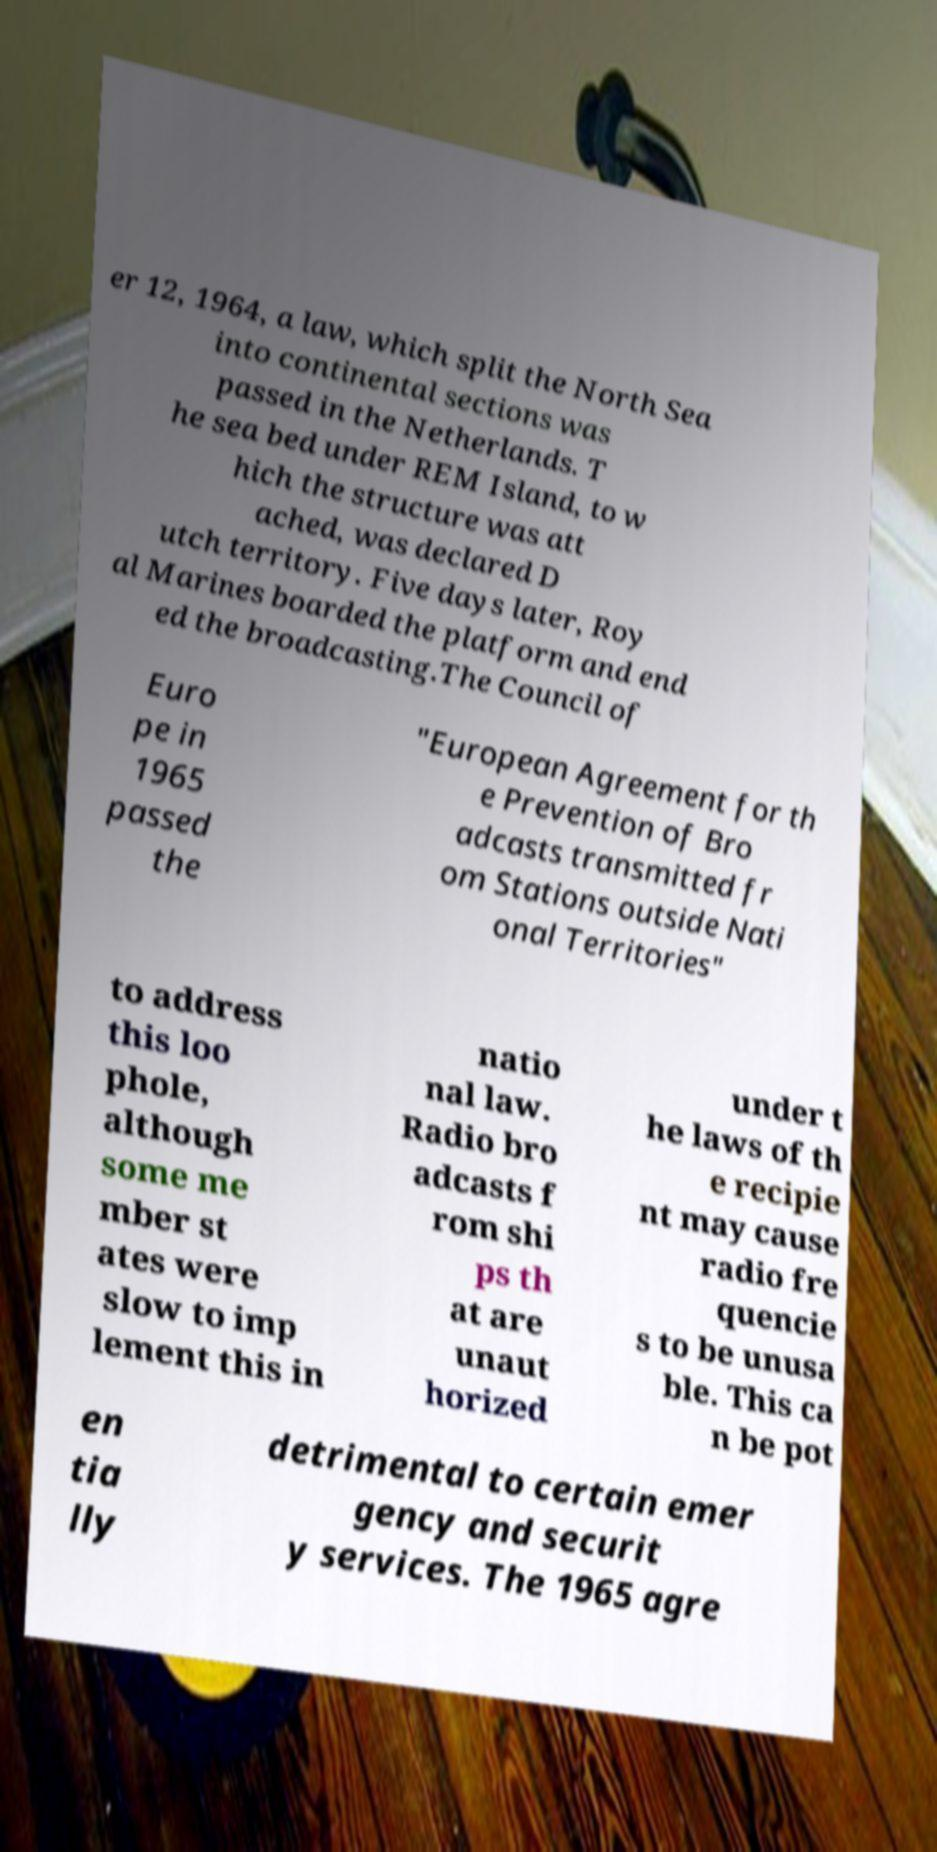Can you read and provide the text displayed in the image?This photo seems to have some interesting text. Can you extract and type it out for me? er 12, 1964, a law, which split the North Sea into continental sections was passed in the Netherlands. T he sea bed under REM Island, to w hich the structure was att ached, was declared D utch territory. Five days later, Roy al Marines boarded the platform and end ed the broadcasting.The Council of Euro pe in 1965 passed the "European Agreement for th e Prevention of Bro adcasts transmitted fr om Stations outside Nati onal Territories" to address this loo phole, although some me mber st ates were slow to imp lement this in natio nal law. Radio bro adcasts f rom shi ps th at are unaut horized under t he laws of th e recipie nt may cause radio fre quencie s to be unusa ble. This ca n be pot en tia lly detrimental to certain emer gency and securit y services. The 1965 agre 